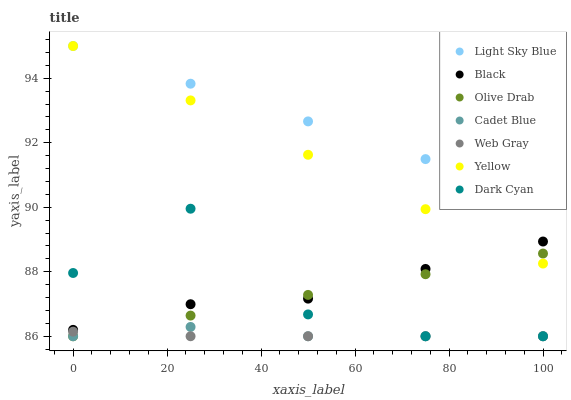Does Web Gray have the minimum area under the curve?
Answer yes or no. Yes. Does Light Sky Blue have the maximum area under the curve?
Answer yes or no. Yes. Does Yellow have the minimum area under the curve?
Answer yes or no. No. Does Yellow have the maximum area under the curve?
Answer yes or no. No. Is Yellow the smoothest?
Answer yes or no. Yes. Is Dark Cyan the roughest?
Answer yes or no. Yes. Is Web Gray the smoothest?
Answer yes or no. No. Is Web Gray the roughest?
Answer yes or no. No. Does Cadet Blue have the lowest value?
Answer yes or no. Yes. Does Yellow have the lowest value?
Answer yes or no. No. Does Light Sky Blue have the highest value?
Answer yes or no. Yes. Does Web Gray have the highest value?
Answer yes or no. No. Is Black less than Light Sky Blue?
Answer yes or no. Yes. Is Light Sky Blue greater than Dark Cyan?
Answer yes or no. Yes. Does Olive Drab intersect Yellow?
Answer yes or no. Yes. Is Olive Drab less than Yellow?
Answer yes or no. No. Is Olive Drab greater than Yellow?
Answer yes or no. No. Does Black intersect Light Sky Blue?
Answer yes or no. No. 